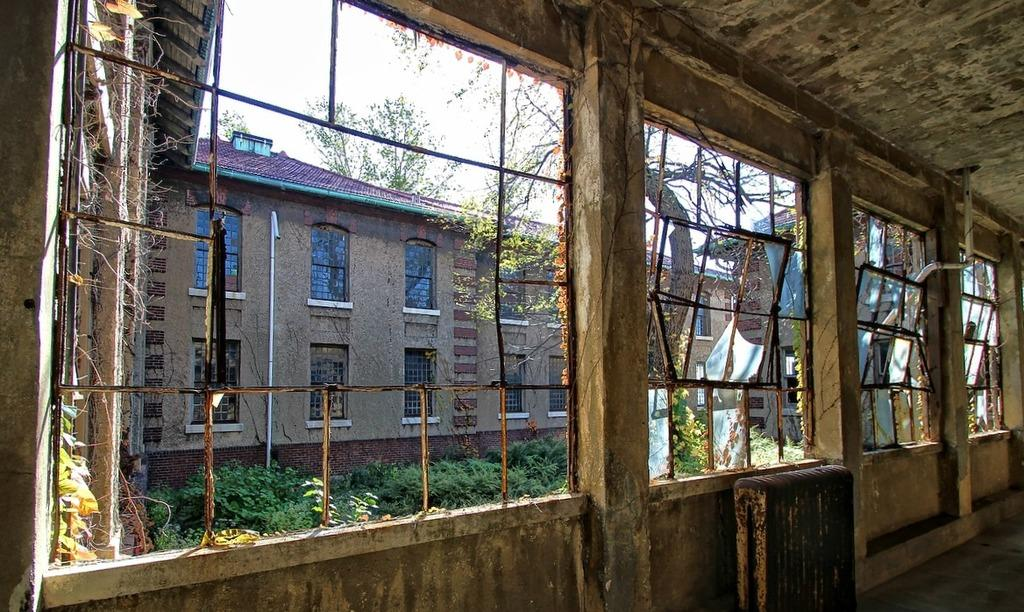What type of structures can be seen in the image? There are buildings in the image. What natural elements are present in the image? There are trees and plants in the image. What type of material is used for the rods visible in the image? Metal rods are visible in the image. Where is the pipe located in the image? There is a pipe on a wall in the image. How many bushes are present in the image? There are no bushes mentioned in the provided facts, so we cannot determine the number of bushes in the image. What is the value of the quarter in the image? There is no mention of a quarter in the provided facts, so we cannot determine its value in the image. 